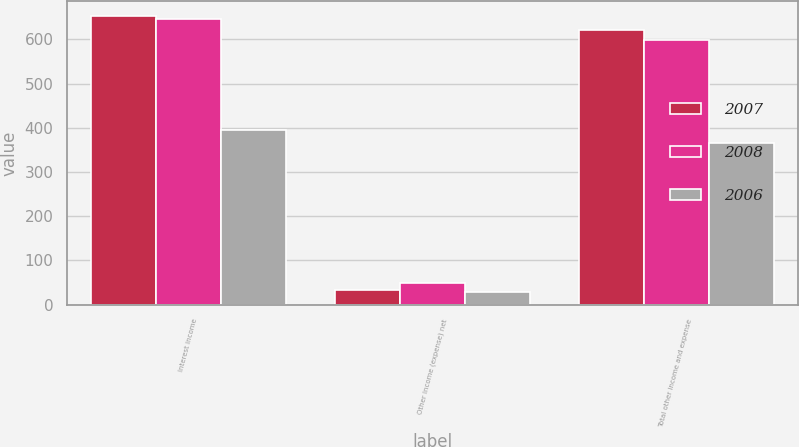Convert chart to OTSL. <chart><loc_0><loc_0><loc_500><loc_500><stacked_bar_chart><ecel><fcel>Interest income<fcel>Other income (expense) net<fcel>Total other income and expense<nl><fcel>2007<fcel>653<fcel>33<fcel>620<nl><fcel>2008<fcel>647<fcel>48<fcel>599<nl><fcel>2006<fcel>394<fcel>29<fcel>365<nl></chart> 